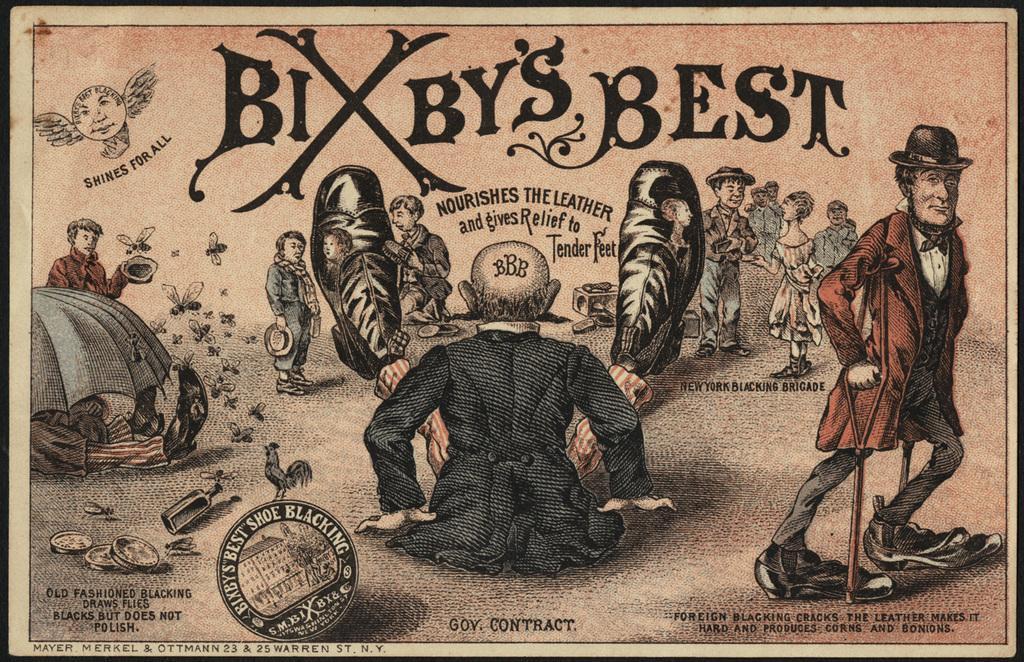Describe this image in one or two sentences. In the image there is an art of few people standing and walking on the land with text above and below it, in the middle there is a man sitting on the floor spreading his legs. 